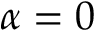<formula> <loc_0><loc_0><loc_500><loc_500>\alpha = 0</formula> 